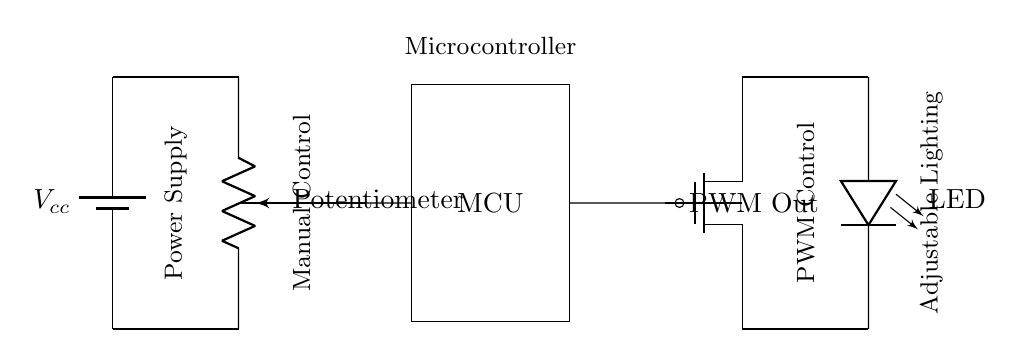What is the type of power supply used in this circuit? The circuit diagram shows a battery symbol which indicates that a battery is used as the power supply. The label on the battery identifies it as Vcc.
Answer: Battery What component is used to control brightness manually? The potentiometer is represented by a pR notation in the circuit, indicating its role in manually adjusting the resistance and thus controlling brightness.
Answer: Potentiometer How does the microcontroller influence LED brightness? The microcontroller outputs a PWM signal that controls the MOSFET, which in turn regulates the power to the LED, allowing for variable brightness based on the PWM duty cycle.
Answer: PWM What is the role of the MOSFET in this circuit? The MOSFET acts as a switch controlled by the PWM signal from the microcontroller, allowing for efficient power management of the LED. It turns on and off rapidly to adjust the average power delivered to the LED.
Answer: Switch What type of lighting is being adjusted in this circuit? The circuit diagram uses an LED symbol, indicating that the lighting being controlled is provided by Light Emitting Diodes.
Answer: LED What does PWM stand for? PWM stands for Pulse Width Modulation, a technique used in the circuit to adjust the power delivered to the LED, effectively changing its brightness.
Answer: Pulse Width Modulation 